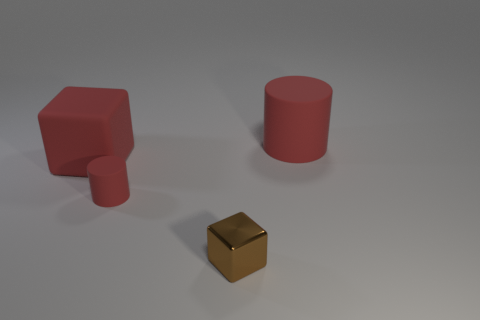There is a large matte thing that is the same color as the rubber cube; what is its shape?
Your answer should be very brief. Cylinder. Is there a big object of the same shape as the tiny brown shiny thing?
Keep it short and to the point. Yes. There is a cylinder that is the same size as the brown object; what is its color?
Your answer should be compact. Red. What number of things are either red cylinders that are in front of the red cube or red cylinders left of the brown block?
Your answer should be compact. 1. What number of objects are either red objects or tiny cylinders?
Offer a terse response. 3. What is the size of the red thing that is behind the tiny rubber thing and on the left side of the shiny block?
Provide a short and direct response. Large. What number of tiny red things have the same material as the brown cube?
Offer a terse response. 0. There is a tiny cylinder that is the same material as the large cylinder; what is its color?
Make the answer very short. Red. There is a cube that is to the left of the small brown cube; is it the same color as the tiny metal object?
Keep it short and to the point. No. What is the material of the cube on the left side of the shiny cube?
Offer a very short reply. Rubber. 